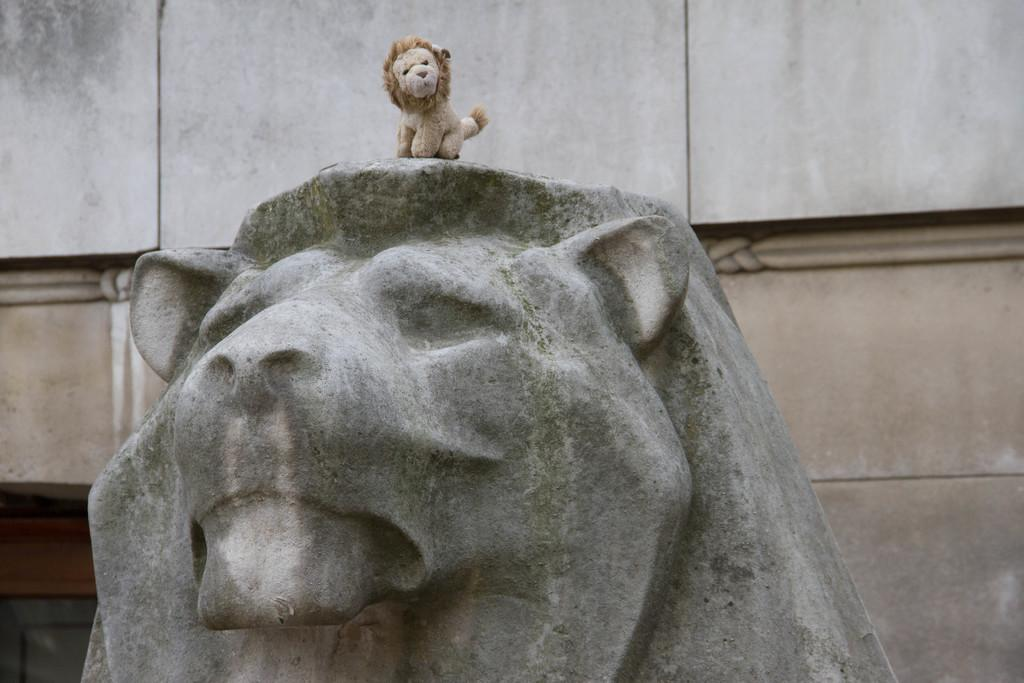What type of animal is depicted in the sculpture in the image? There is a sculpture of a lion in the image. What other object related to a lion can be seen in the image? There is a toy lion in the image. What is visible in the background of the image? There is a wall in the background of the image. What type of thread is used to create the lion's mane in the image? There is no thread present in the image, as the lion is depicted as a sculpture and a toy. 